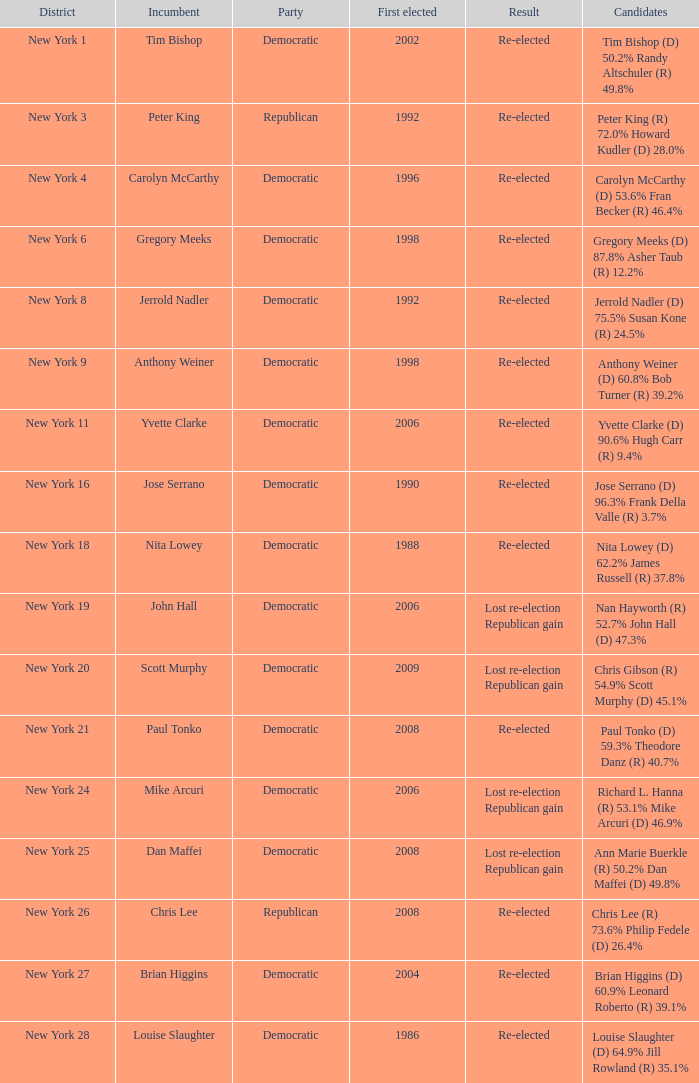Name the first elected for re-elected and brian higgins 2004.0. 